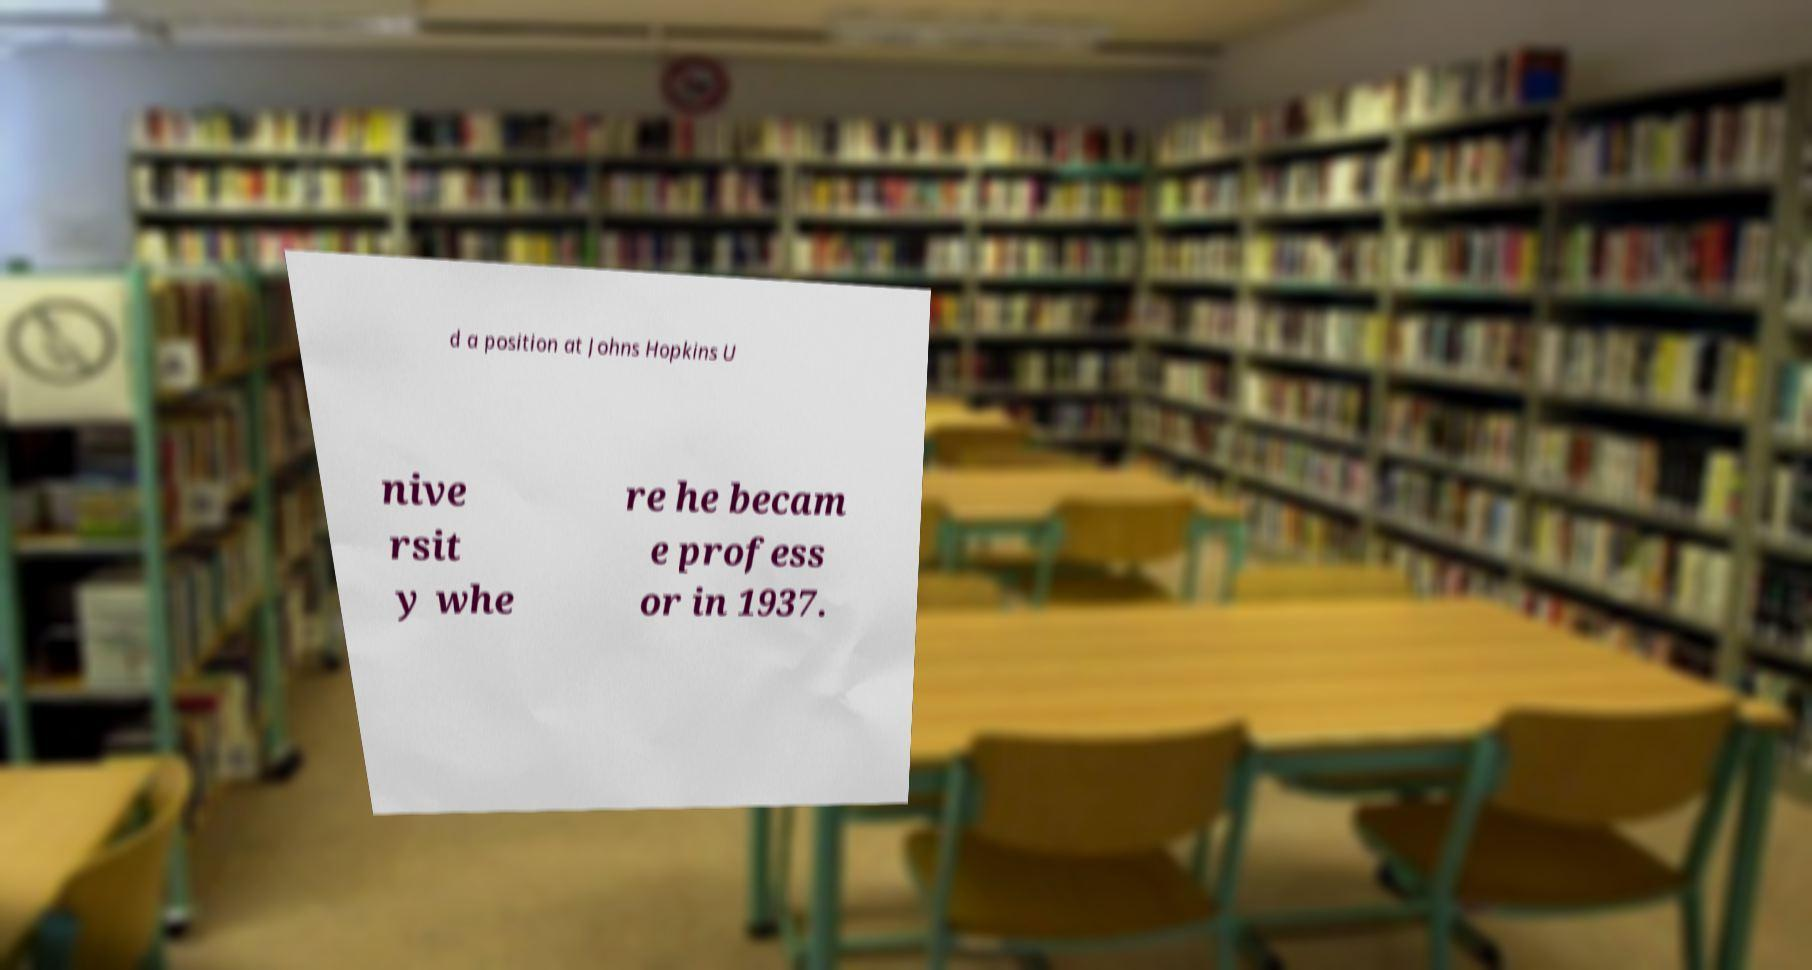Could you extract and type out the text from this image? d a position at Johns Hopkins U nive rsit y whe re he becam e profess or in 1937. 